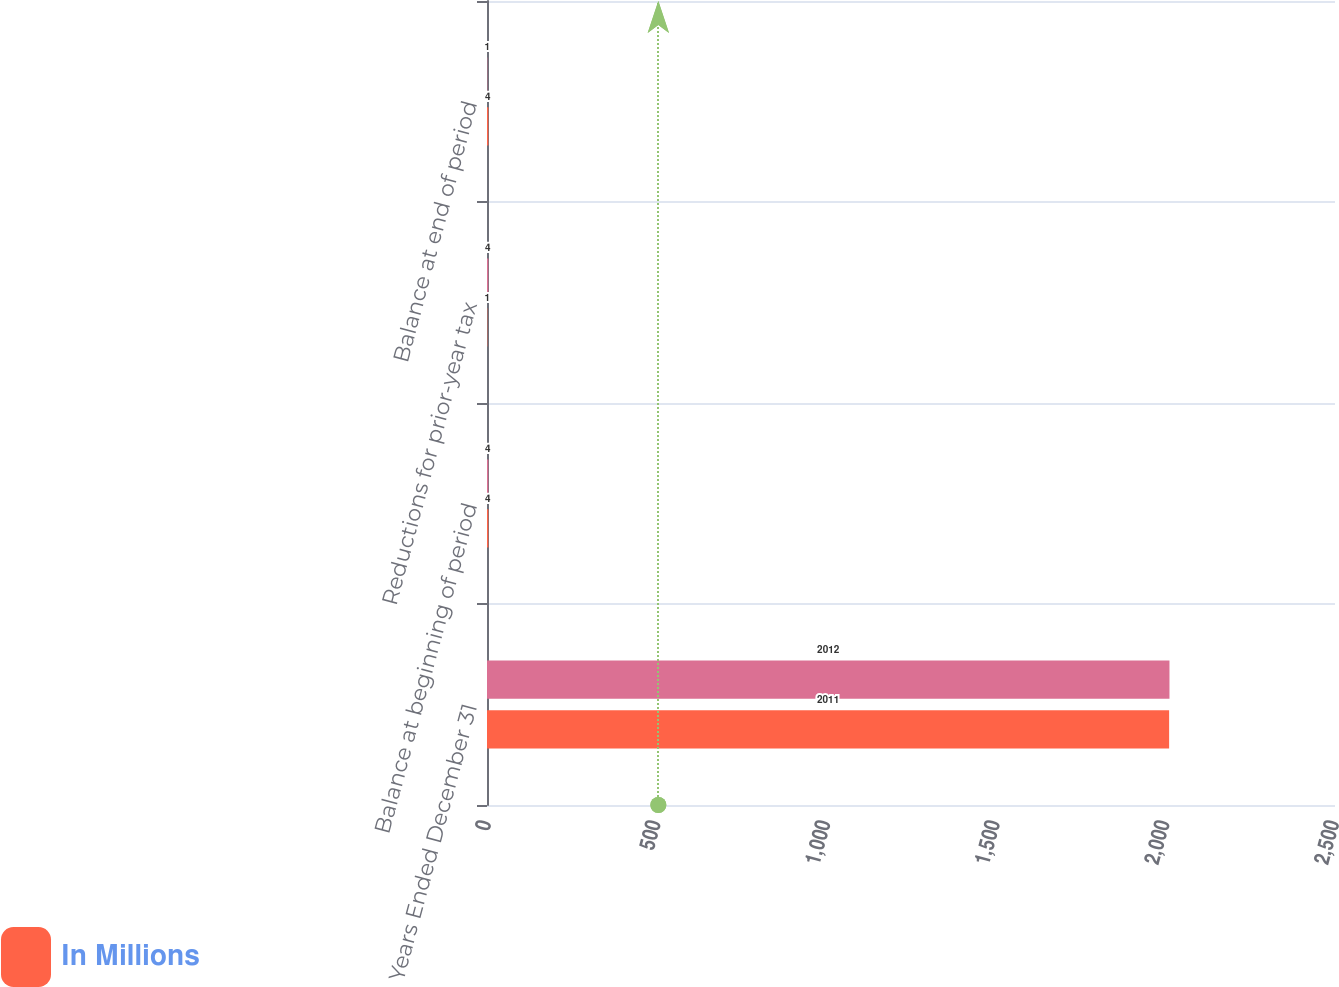<chart> <loc_0><loc_0><loc_500><loc_500><stacked_bar_chart><ecel><fcel>Years Ended December 31<fcel>Balance at beginning of period<fcel>Reductions for prior-year tax<fcel>Balance at end of period<nl><fcel>nan<fcel>2012<fcel>4<fcel>4<fcel>1<nl><fcel>In Millions<fcel>2011<fcel>4<fcel>1<fcel>4<nl></chart> 